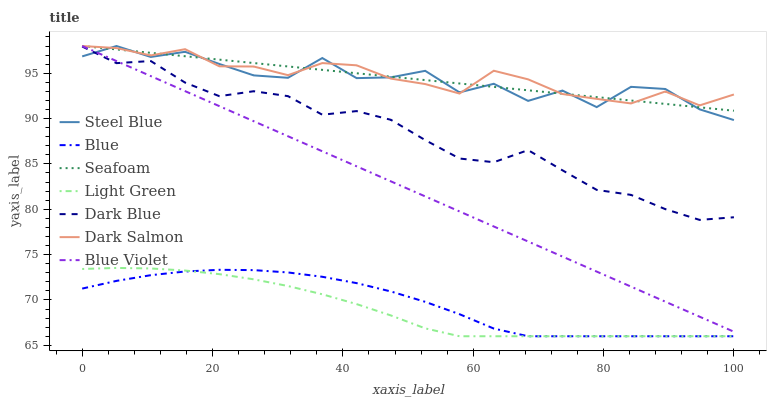Does Light Green have the minimum area under the curve?
Answer yes or no. Yes. Does Dark Salmon have the maximum area under the curve?
Answer yes or no. Yes. Does Seafoam have the minimum area under the curve?
Answer yes or no. No. Does Seafoam have the maximum area under the curve?
Answer yes or no. No. Is Seafoam the smoothest?
Answer yes or no. Yes. Is Steel Blue the roughest?
Answer yes or no. Yes. Is Dark Salmon the smoothest?
Answer yes or no. No. Is Dark Salmon the roughest?
Answer yes or no. No. Does Blue have the lowest value?
Answer yes or no. Yes. Does Seafoam have the lowest value?
Answer yes or no. No. Does Blue Violet have the highest value?
Answer yes or no. Yes. Does Dark Blue have the highest value?
Answer yes or no. No. Is Light Green less than Seafoam?
Answer yes or no. Yes. Is Steel Blue greater than Blue?
Answer yes or no. Yes. Does Dark Salmon intersect Blue Violet?
Answer yes or no. Yes. Is Dark Salmon less than Blue Violet?
Answer yes or no. No. Is Dark Salmon greater than Blue Violet?
Answer yes or no. No. Does Light Green intersect Seafoam?
Answer yes or no. No. 